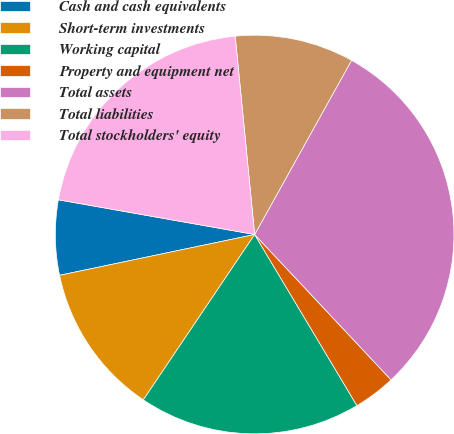<chart> <loc_0><loc_0><loc_500><loc_500><pie_chart><fcel>Cash and cash equivalents<fcel>Short-term investments<fcel>Working capital<fcel>Property and equipment net<fcel>Total assets<fcel>Total liabilities<fcel>Total stockholders' equity<nl><fcel>6.07%<fcel>12.29%<fcel>18.01%<fcel>3.42%<fcel>29.93%<fcel>9.64%<fcel>20.66%<nl></chart> 